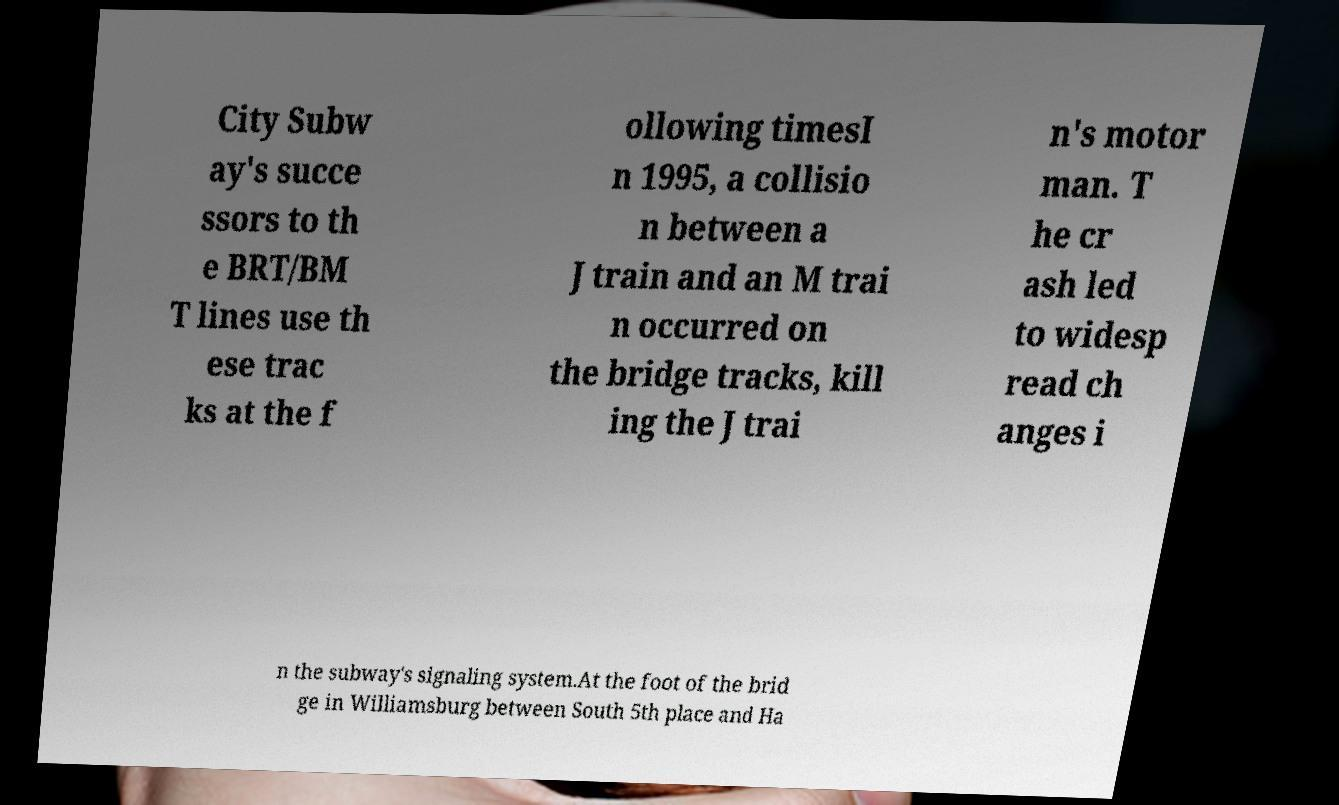Could you extract and type out the text from this image? City Subw ay's succe ssors to th e BRT/BM T lines use th ese trac ks at the f ollowing timesI n 1995, a collisio n between a J train and an M trai n occurred on the bridge tracks, kill ing the J trai n's motor man. T he cr ash led to widesp read ch anges i n the subway's signaling system.At the foot of the brid ge in Williamsburg between South 5th place and Ha 